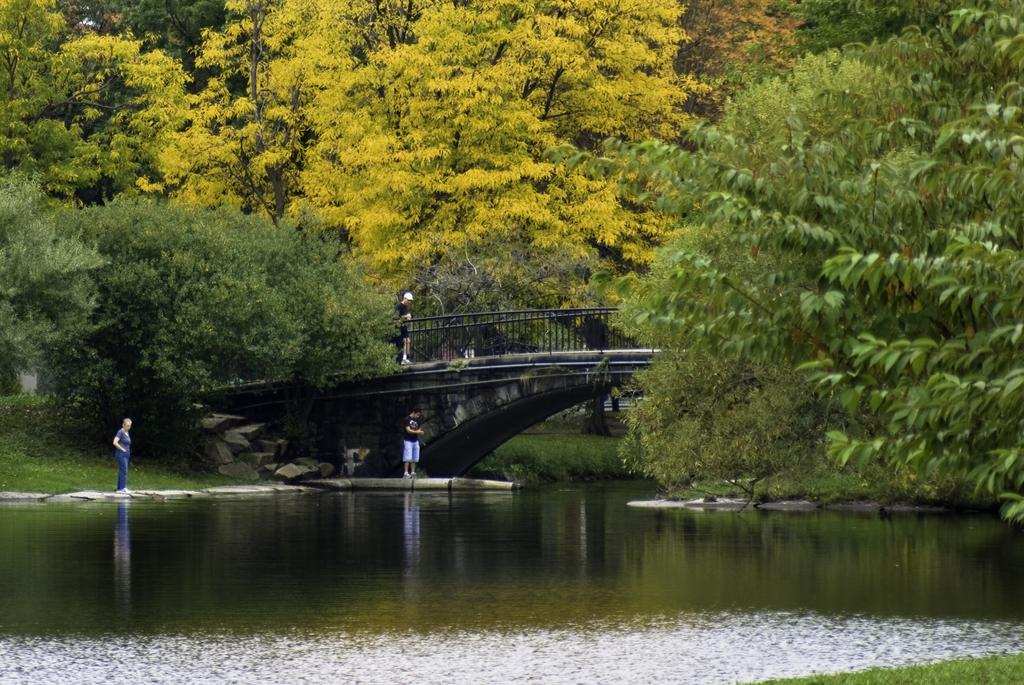What structure can be seen in the image? There is a bridge in the image. What natural element is visible in the image? There is water visible in the image. Can you describe the person in the image? There is a person standing in the image. What type of vegetation is present in the image? There are trees in the image. What type of popcorn is being held by the person in the image? There is no popcorn present in the image; the person is not holding any. How many hands does the light in the image have? There is no light present in the image, so it does not have any hands. 